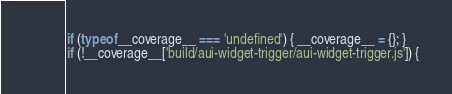Convert code to text. <code><loc_0><loc_0><loc_500><loc_500><_JavaScript_>if (typeof __coverage__ === 'undefined') { __coverage__ = {}; }
if (!__coverage__['build/aui-widget-trigger/aui-widget-trigger.js']) {</code> 